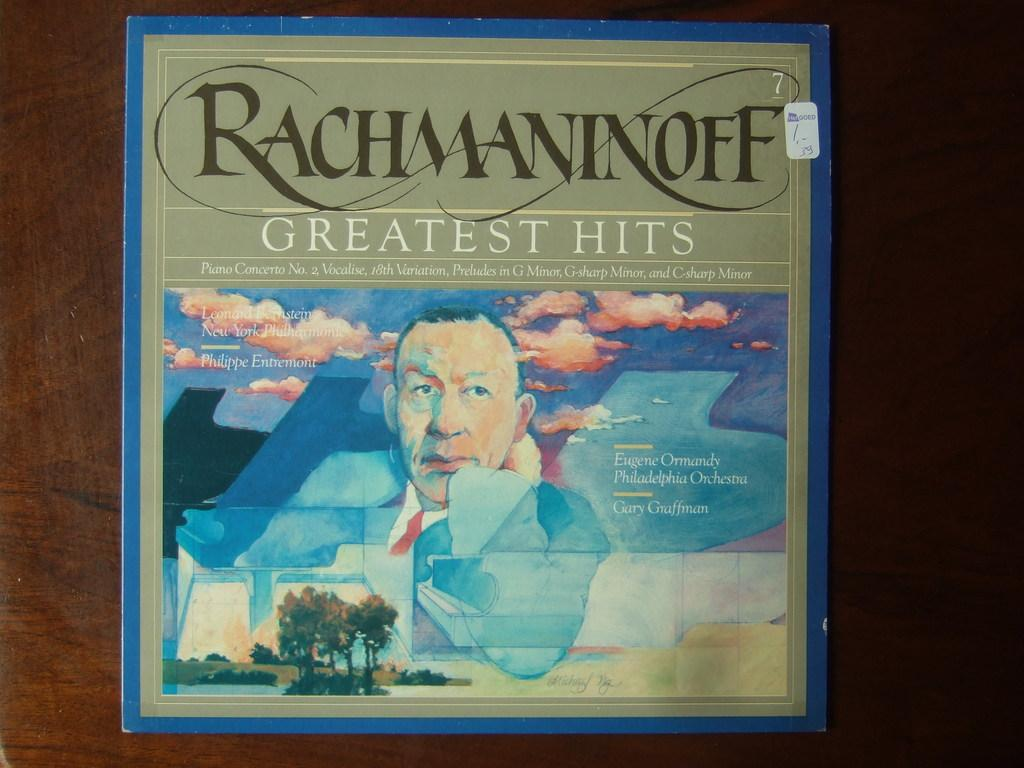<image>
Write a terse but informative summary of the picture. A record cover of Rachmaninoff Greatest Hits outlined in blue. 